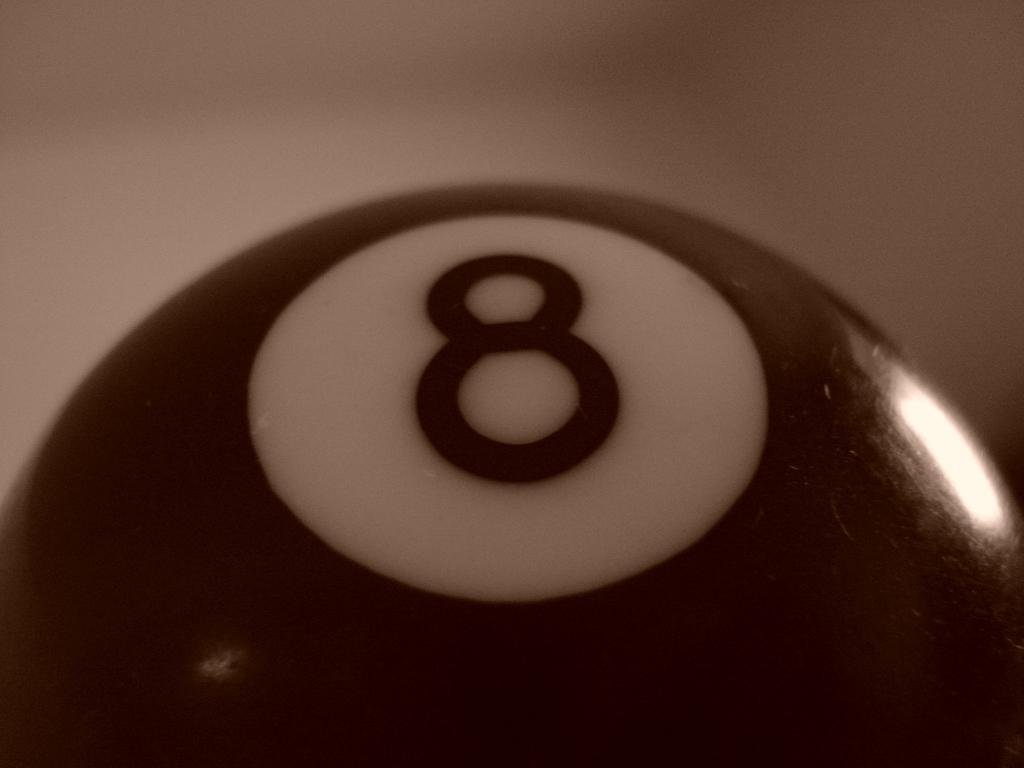What is the main object in the image? There is a black ball in the image. the image. Where is the black ball located? The black ball is in a ball pool. What type of love can be seen between the black ball and the ball pool in the image? There is no indication of love or any emotional connection between the black ball and the ball pool in the image. 